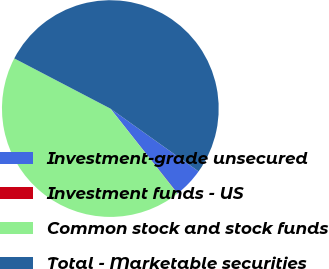Convert chart to OTSL. <chart><loc_0><loc_0><loc_500><loc_500><pie_chart><fcel>Investment-grade unsecured<fcel>Investment funds - US<fcel>Common stock and stock funds<fcel>Total - Marketable securities<nl><fcel>4.48%<fcel>0.03%<fcel>43.3%<fcel>52.2%<nl></chart> 